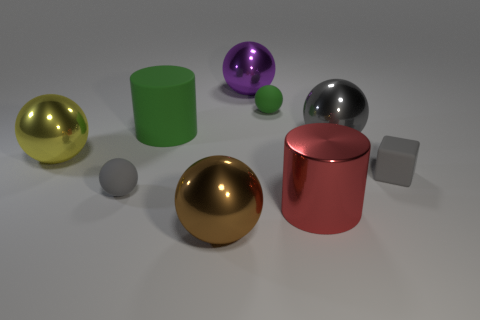Subtract 3 spheres. How many spheres are left? 3 Subtract all purple spheres. How many spheres are left? 5 Subtract all green balls. How many balls are left? 5 Subtract all brown balls. Subtract all brown cylinders. How many balls are left? 5 Subtract all balls. How many objects are left? 3 Subtract all tiny shiny cylinders. Subtract all purple shiny spheres. How many objects are left? 8 Add 1 big gray metal objects. How many big gray metal objects are left? 2 Add 3 purple metallic objects. How many purple metallic objects exist? 4 Subtract 0 red blocks. How many objects are left? 9 